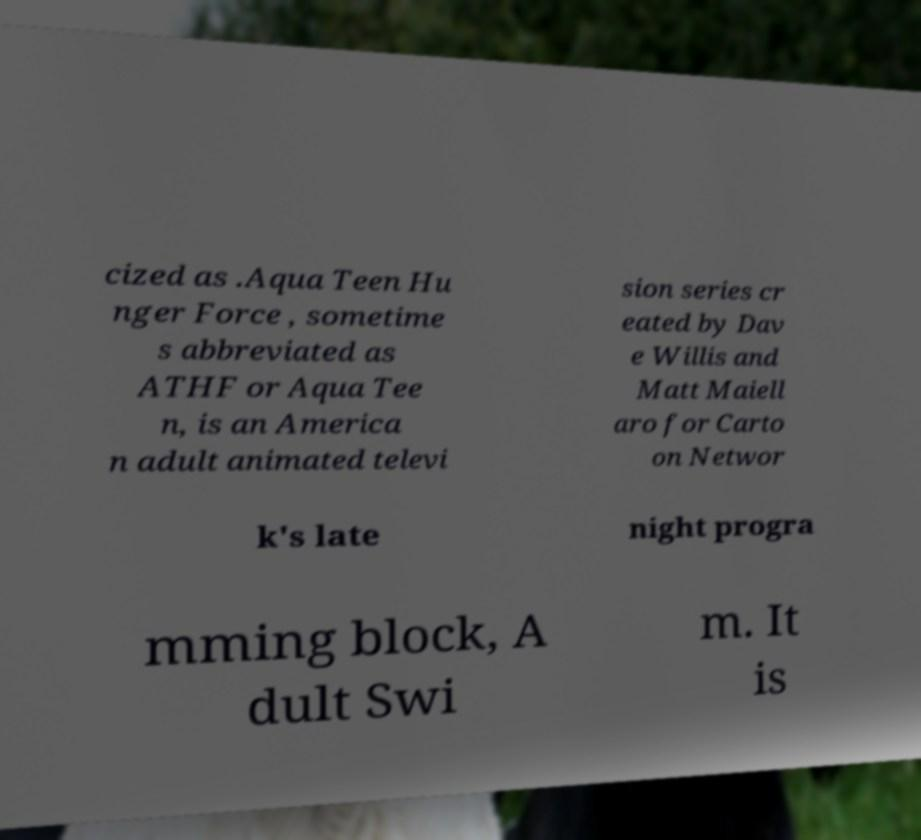Could you assist in decoding the text presented in this image and type it out clearly? cized as .Aqua Teen Hu nger Force , sometime s abbreviated as ATHF or Aqua Tee n, is an America n adult animated televi sion series cr eated by Dav e Willis and Matt Maiell aro for Carto on Networ k's late night progra mming block, A dult Swi m. It is 